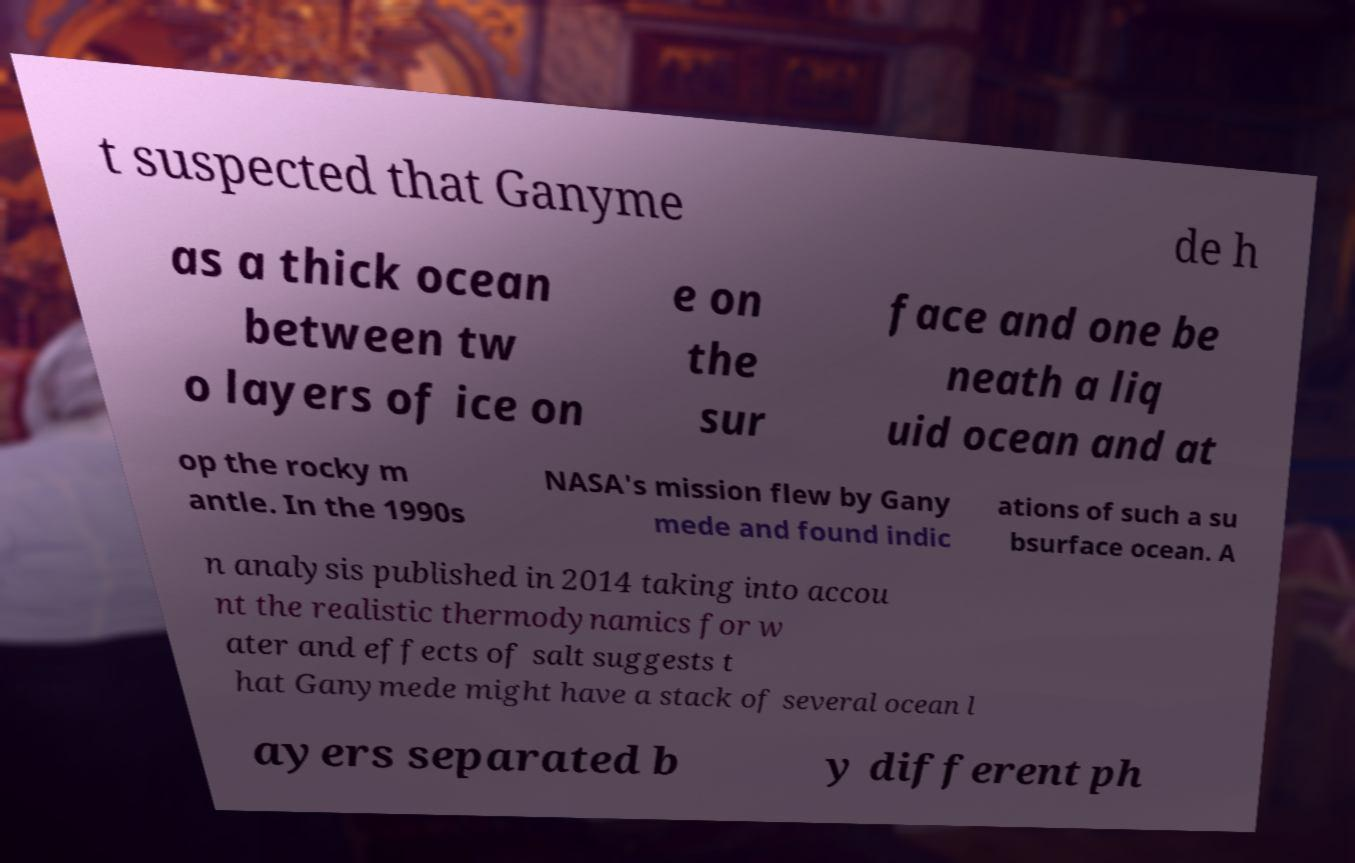Can you read and provide the text displayed in the image?This photo seems to have some interesting text. Can you extract and type it out for me? t suspected that Ganyme de h as a thick ocean between tw o layers of ice on e on the sur face and one be neath a liq uid ocean and at op the rocky m antle. In the 1990s NASA's mission flew by Gany mede and found indic ations of such a su bsurface ocean. A n analysis published in 2014 taking into accou nt the realistic thermodynamics for w ater and effects of salt suggests t hat Ganymede might have a stack of several ocean l ayers separated b y different ph 